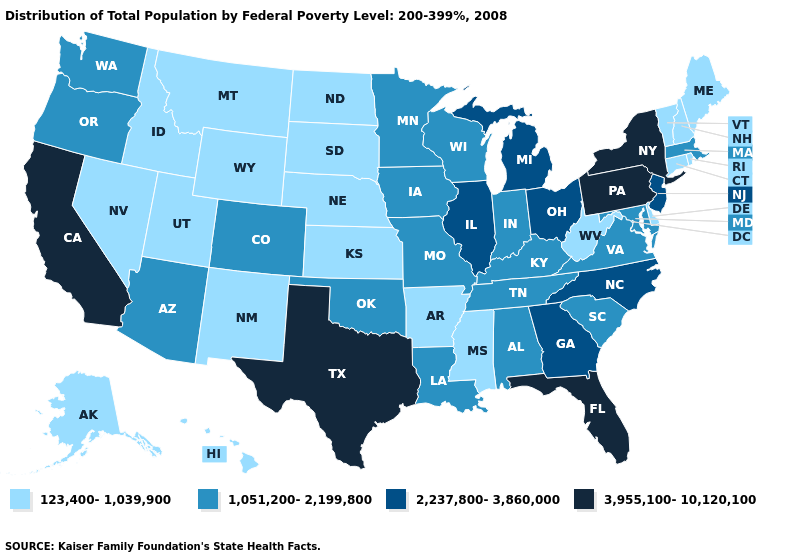Which states hav the highest value in the West?
Give a very brief answer. California. What is the value of Montana?
Answer briefly. 123,400-1,039,900. Among the states that border Colorado , does Wyoming have the lowest value?
Write a very short answer. Yes. What is the value of Washington?
Quick response, please. 1,051,200-2,199,800. Does California have the highest value in the USA?
Short answer required. Yes. Name the states that have a value in the range 1,051,200-2,199,800?
Give a very brief answer. Alabama, Arizona, Colorado, Indiana, Iowa, Kentucky, Louisiana, Maryland, Massachusetts, Minnesota, Missouri, Oklahoma, Oregon, South Carolina, Tennessee, Virginia, Washington, Wisconsin. What is the value of Pennsylvania?
Give a very brief answer. 3,955,100-10,120,100. Is the legend a continuous bar?
Write a very short answer. No. Which states have the lowest value in the USA?
Give a very brief answer. Alaska, Arkansas, Connecticut, Delaware, Hawaii, Idaho, Kansas, Maine, Mississippi, Montana, Nebraska, Nevada, New Hampshire, New Mexico, North Dakota, Rhode Island, South Dakota, Utah, Vermont, West Virginia, Wyoming. Among the states that border West Virginia , which have the lowest value?
Be succinct. Kentucky, Maryland, Virginia. Does Wyoming have the same value as North Carolina?
Write a very short answer. No. Does Colorado have the highest value in the USA?
Write a very short answer. No. What is the value of Illinois?
Write a very short answer. 2,237,800-3,860,000. What is the value of Georgia?
Quick response, please. 2,237,800-3,860,000. Among the states that border Michigan , does Wisconsin have the highest value?
Answer briefly. No. 